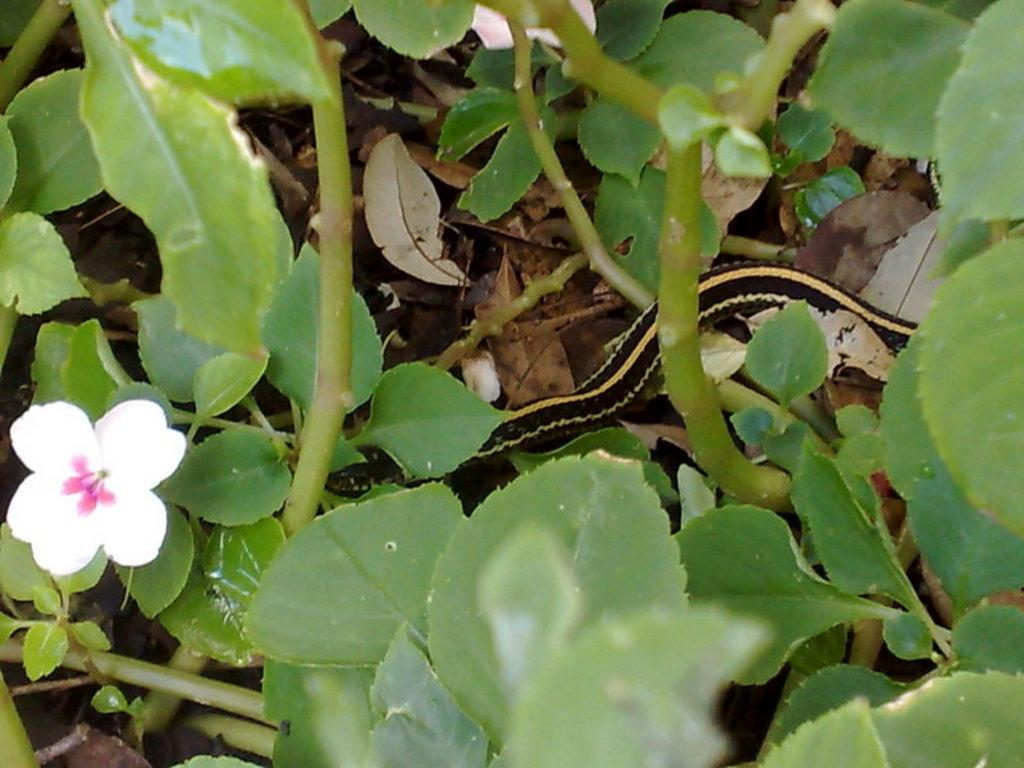What is located in the bottom left corner of the image? There is a flower in the bottom left corner of the image. What can be seen in the middle of the image? There is a snake in the middle of the image. What type of button can be seen on the map in the image? There is no map or button present in the image; it features a flower in the bottom left corner and a snake in the middle. What adjustment can be made to the snake in the image? There is no adjustment to be made to the snake in the image, as it is a static representation. 